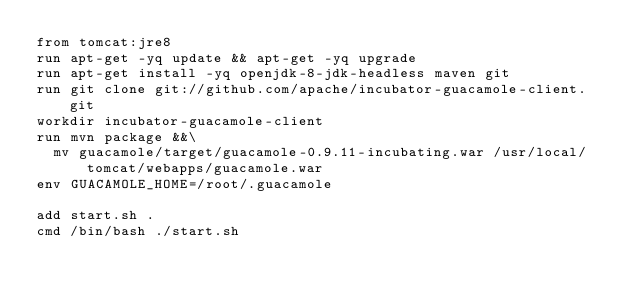<code> <loc_0><loc_0><loc_500><loc_500><_Dockerfile_>from tomcat:jre8
run apt-get -yq update && apt-get -yq upgrade
run apt-get install -yq openjdk-8-jdk-headless maven git
run git clone git://github.com/apache/incubator-guacamole-client.git
workdir incubator-guacamole-client
run mvn package &&\
  mv guacamole/target/guacamole-0.9.11-incubating.war /usr/local/tomcat/webapps/guacamole.war
env GUACAMOLE_HOME=/root/.guacamole

add start.sh .
cmd /bin/bash ./start.sh
</code> 